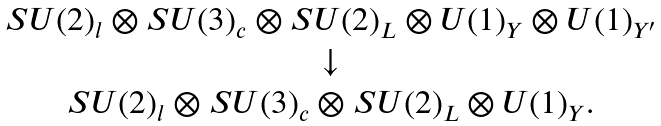Convert formula to latex. <formula><loc_0><loc_0><loc_500><loc_500>\begin{array} { c } S U ( 2 ) _ { l } \otimes S U ( 3 ) _ { c } \otimes S U ( 2 ) _ { L } \otimes U ( 1 ) _ { Y } \otimes U ( 1 ) _ { Y ^ { \prime } } \\ \downarrow \\ S U ( 2 ) _ { l } \otimes S U ( 3 ) _ { c } \otimes S U ( 2 ) _ { L } \otimes U ( 1 ) _ { Y } . \end{array}</formula> 